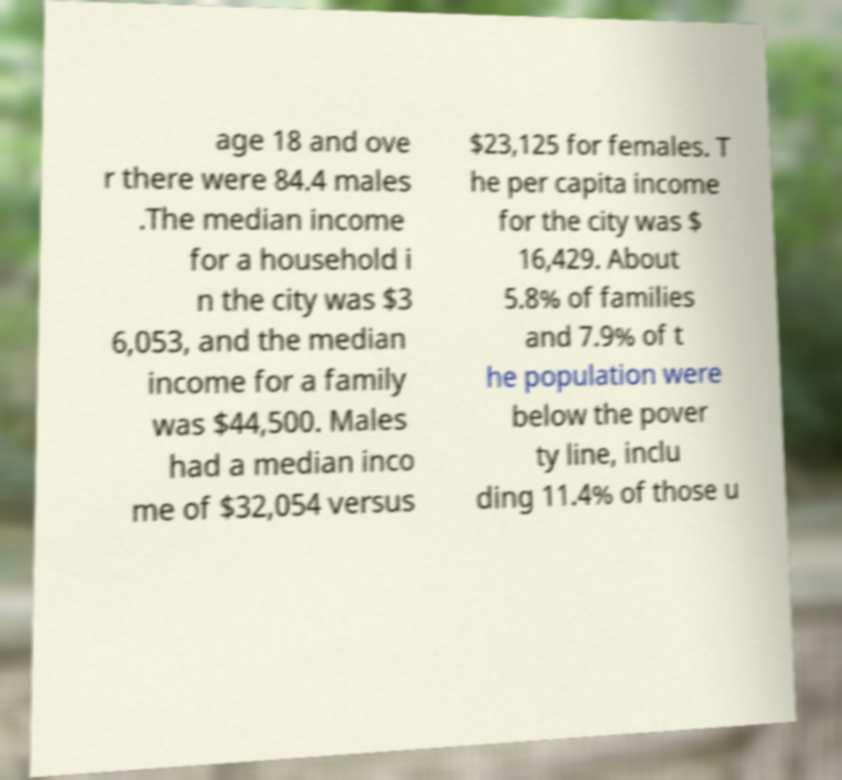Can you accurately transcribe the text from the provided image for me? age 18 and ove r there were 84.4 males .The median income for a household i n the city was $3 6,053, and the median income for a family was $44,500. Males had a median inco me of $32,054 versus $23,125 for females. T he per capita income for the city was $ 16,429. About 5.8% of families and 7.9% of t he population were below the pover ty line, inclu ding 11.4% of those u 